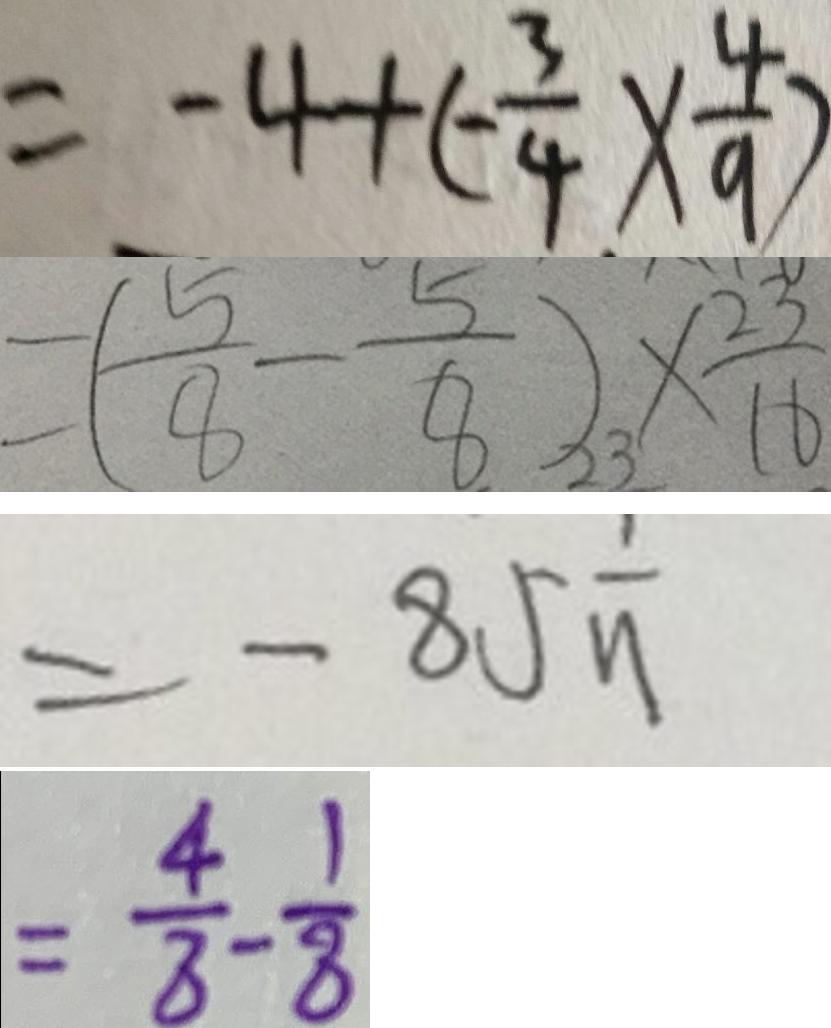<formula> <loc_0><loc_0><loc_500><loc_500>= - 4 + ( - \frac { 3 } { 4 } ) \times \frac { 4 } { 9 } ) 
 = ( \frac { 5 } { 8 } - \frac { 5 } { 8 } ) \times \frac { 2 3 } { 1 6 } 
 = - 8 5 \frac { 1 } { 1 1 } 
 = \frac { 4 } { 8 } - \frac { 1 } { 8 }</formula> 